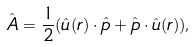Convert formula to latex. <formula><loc_0><loc_0><loc_500><loc_500>\hat { A } = \frac { 1 } { 2 } ( \hat { u } ( { r } ) \cdot \hat { p } + \hat { p } \cdot \hat { u } ( { r } ) ) ,</formula> 